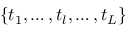Convert formula to latex. <formula><loc_0><loc_0><loc_500><loc_500>\{ t _ { 1 } , \dots , t _ { l } , \dots , t _ { L } \}</formula> 